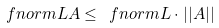Convert formula to latex. <formula><loc_0><loc_0><loc_500><loc_500>\ f n o r m { L A } \leq \ f n o r m L \cdot | | A | |</formula> 